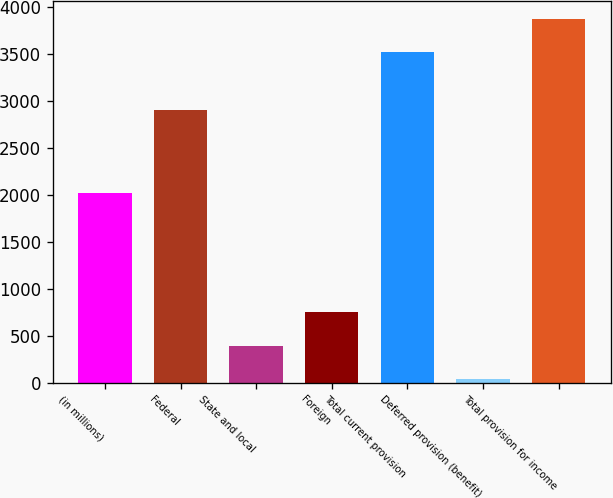<chart> <loc_0><loc_0><loc_500><loc_500><bar_chart><fcel>(in millions)<fcel>Federal<fcel>State and local<fcel>Foreign<fcel>Total current provision<fcel>Deferred provision (benefit)<fcel>Total provision for income<nl><fcel>2018<fcel>2897<fcel>394<fcel>746<fcel>3520<fcel>42<fcel>3872<nl></chart> 